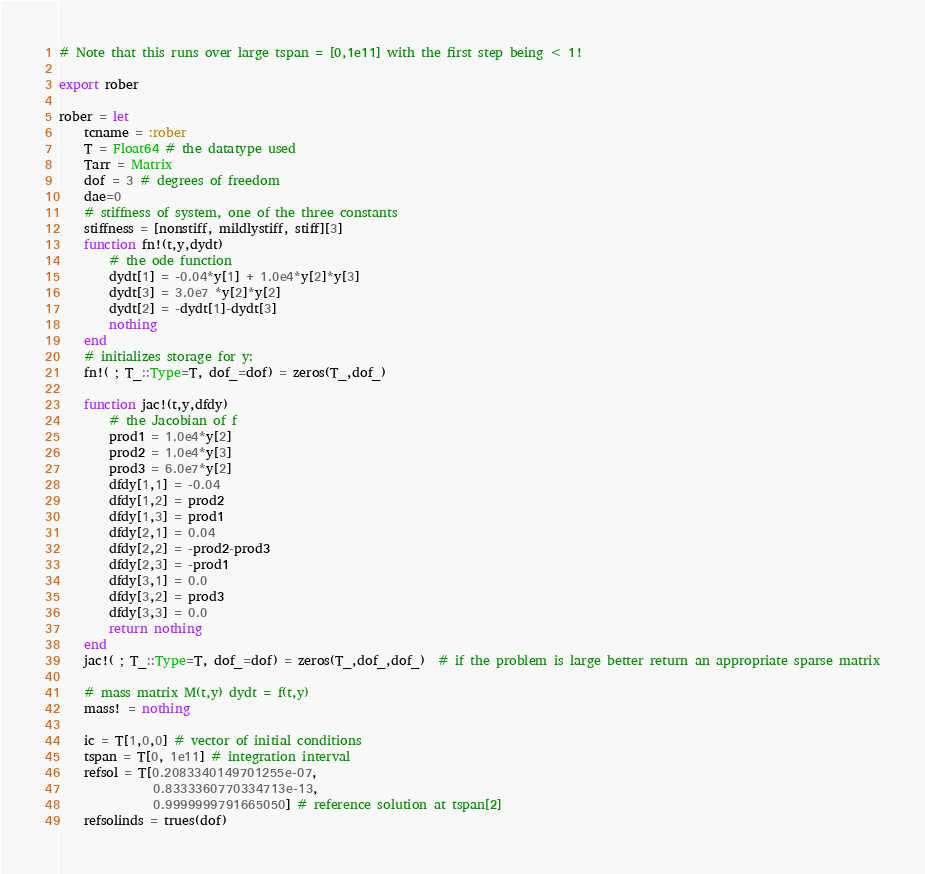Convert code to text. <code><loc_0><loc_0><loc_500><loc_500><_Julia_># Note that this runs over large tspan = [0,1e11] with the first step being < 1!

export rober

rober = let
    tcname = :rober
    T = Float64 # the datatype used
    Tarr = Matrix
    dof = 3 # degrees of freedom
    dae=0
    # stiffness of system, one of the three constants
    stiffness = [nonstiff, mildlystiff, stiff][3] 
    function fn!(t,y,dydt)
        # the ode function
        dydt[1] = -0.04*y[1] + 1.0e4*y[2]*y[3]
        dydt[3] = 3.0e7 *y[2]*y[2]
        dydt[2] = -dydt[1]-dydt[3]
        nothing
    end
    # initializes storage for y:
    fn!( ; T_::Type=T, dof_=dof) = zeros(T_,dof_)
    
    function jac!(t,y,dfdy)
        # the Jacobian of f
        prod1 = 1.0e4*y[2]
        prod2 = 1.0e4*y[3]
        prod3 = 6.0e7*y[2]
        dfdy[1,1] = -0.04
        dfdy[1,2] = prod2
        dfdy[1,3] = prod1
        dfdy[2,1] = 0.04
        dfdy[2,2] = -prod2-prod3
        dfdy[2,3] = -prod1
        dfdy[3,1] = 0.0
        dfdy[3,2] = prod3
        dfdy[3,3] = 0.0
        return nothing
    end
    jac!( ; T_::Type=T, dof_=dof) = zeros(T_,dof_,dof_)  # if the problem is large better return an appropriate sparse matrix

    # mass matrix M(t,y) dydt = f(t,y)
    mass! = nothing
    
    ic = T[1,0,0] # vector of initial conditions
    tspan = T[0, 1e11] # integration interval
    refsol = T[0.2083340149701255e-07,
               0.8333360770334713e-13,
               0.9999999791665050] # reference solution at tspan[2]
    refsolinds = trues(dof)</code> 